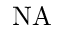Convert formula to latex. <formula><loc_0><loc_0><loc_500><loc_500>N A</formula> 